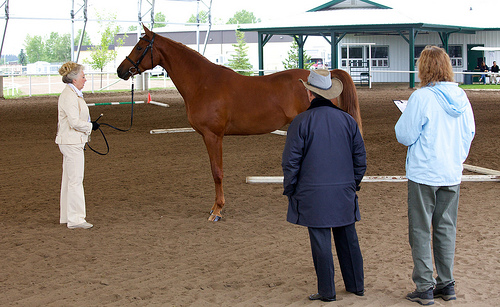<image>
Is there a man on the horse? No. The man is not positioned on the horse. They may be near each other, but the man is not supported by or resting on top of the horse. 